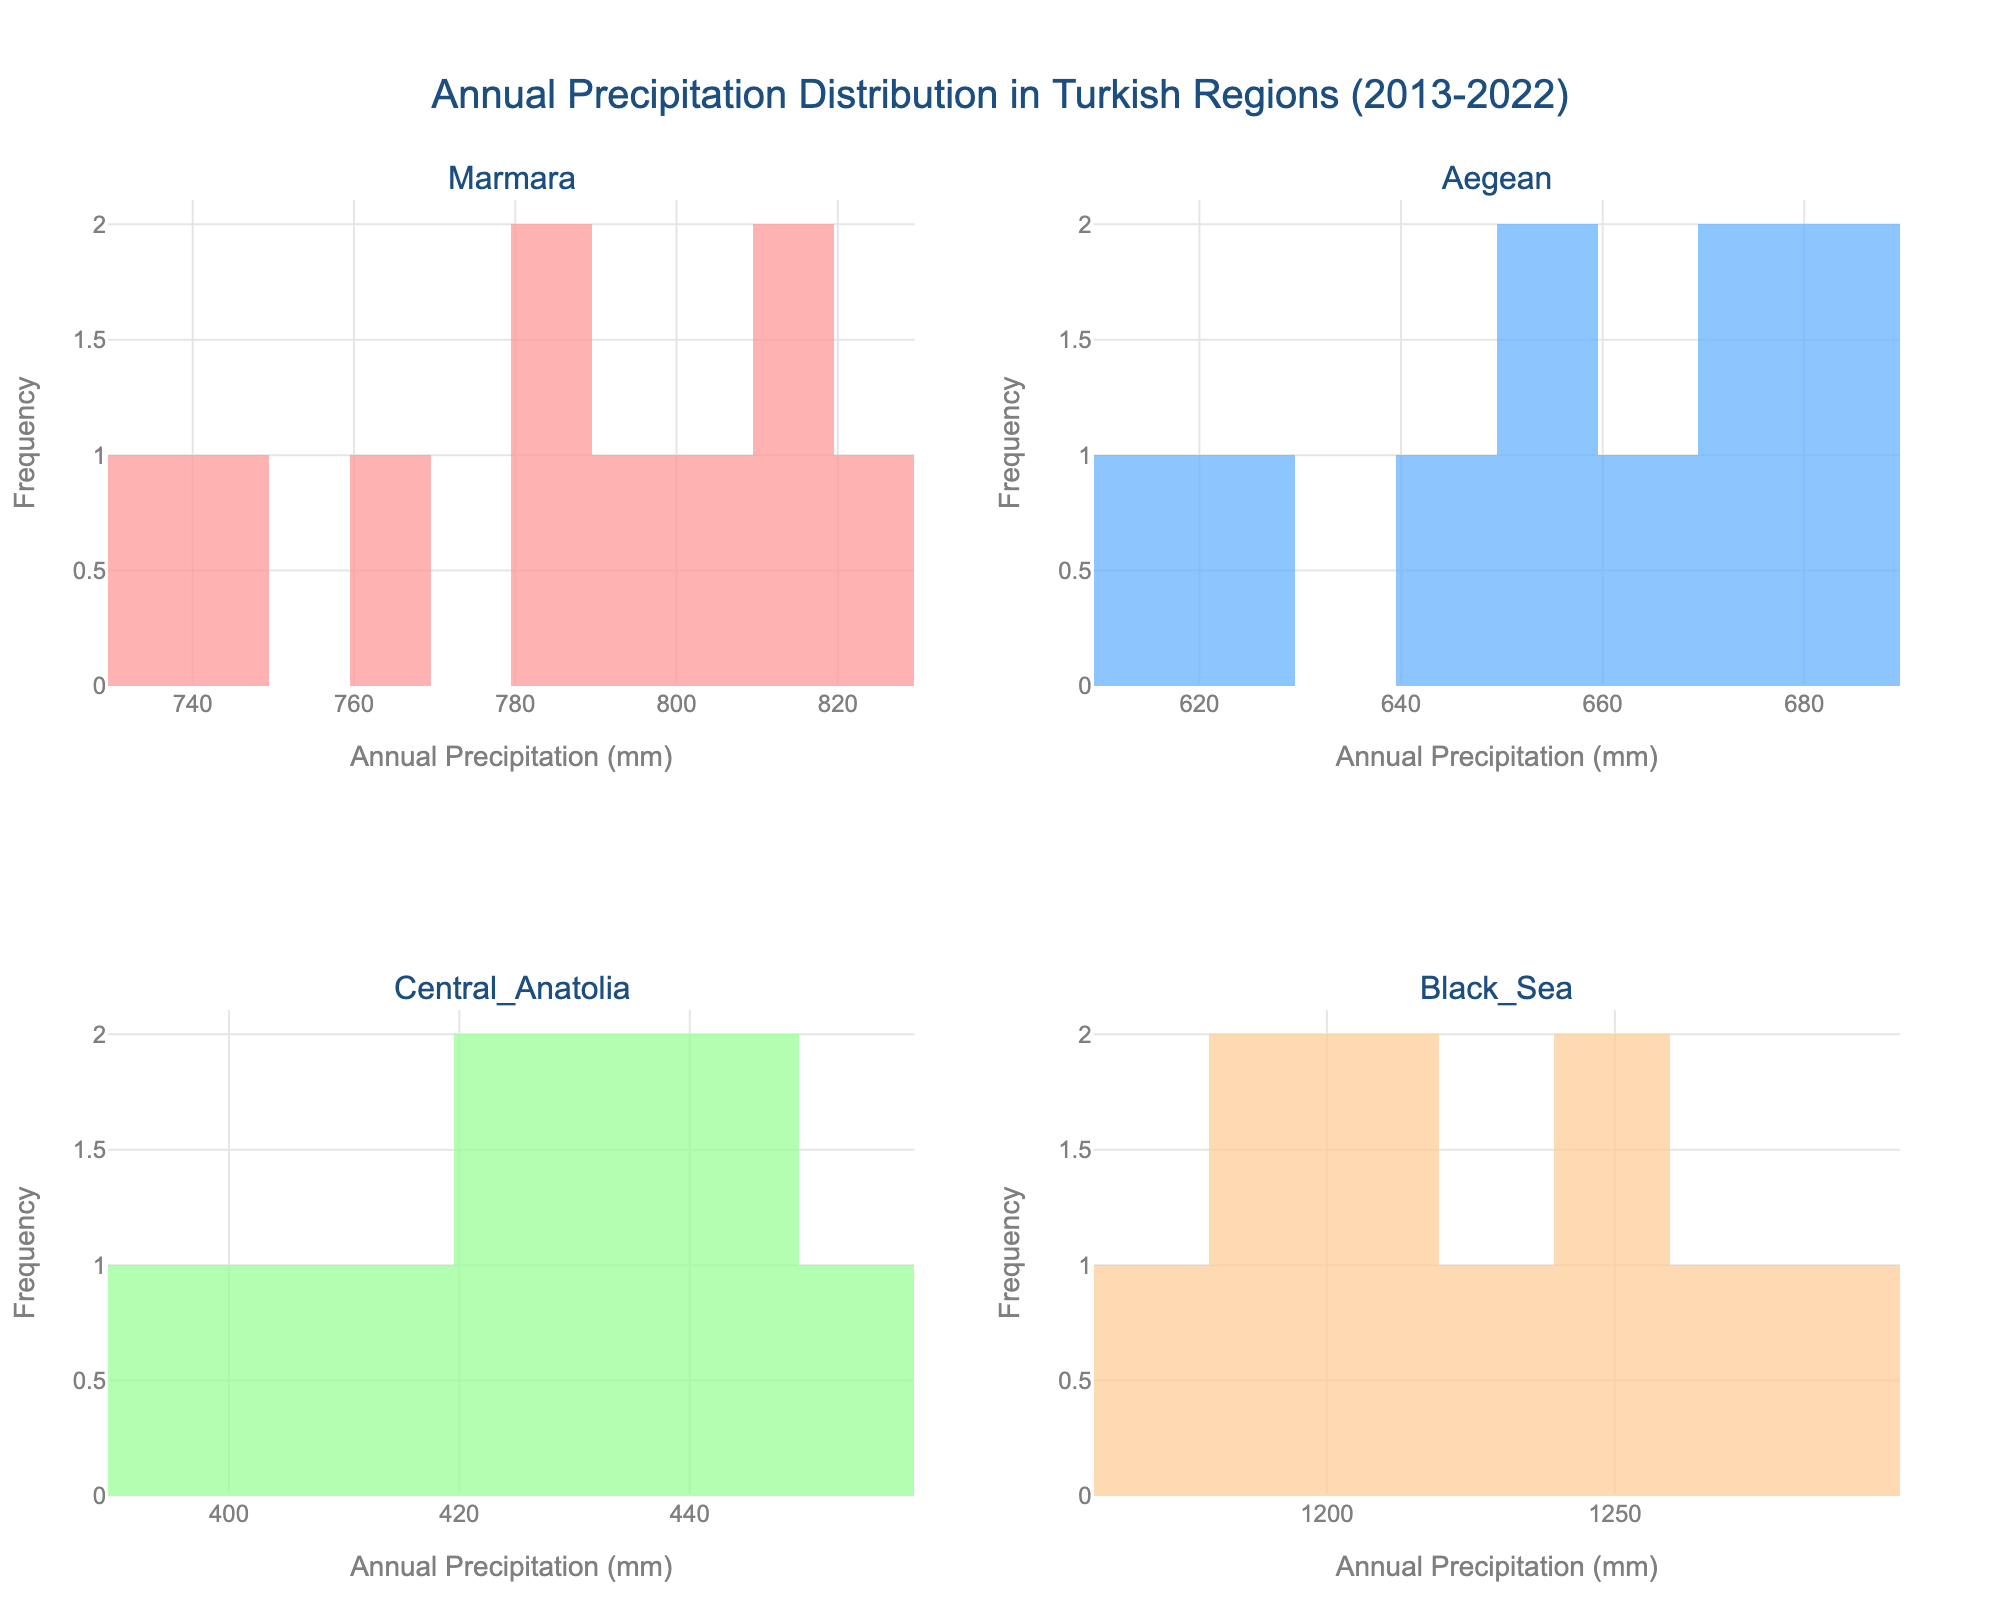What title does the figure have? The title is located at the top of the figure. It reads "Annual Precipitation Distribution in Turkish Regions (2013-2022)".
Answer: Annual Precipitation Distribution in Turkish Regions (2013-2022) What is the highest bin value for the Black Sea region? Observe the histogram for the Black Sea region. Identify the bin with the highest value on the y-axis, which represents frequency.
Answer: 2 Which region experienced the highest annual precipitation? Look for the region with the highest precipitation value on the x-axis of histograms. The Black Sea region's histogram has bins extending up to 1280 mm.
Answer: Black Sea How does the average annual precipitation in the Aegean region compare to the Marmara region? Calculate the average by summing the annual precipitation values for each region and dividing by the number of years. Compare the two averages.
Answer: Marmara is higher What is the most common annual precipitation range for Central Anatolia? Identify the x-axis range with the highest frequency (y-axis) in the Central Anatolia histogram. The most frequent bin range represents the common precipitation range.
Answer: 410-420 mm Which region shows the greatest variability in annual precipitation? Evaluate the spread of the distributions. Wider distributions indicate greater variability. The Black Sea region has the widest spread in its histogram.
Answer: Black Sea In which region is the annual precipitation most consistent? The region with the narrowest spread in the histogram indicates consistent precipitation. Central Anatolia's histogram shows a narrow spread.
Answer: Central Anatolia How do the frequencies of the highest precipitation bins in Marmara and Aegean compare? Identify the bins with the highest precipitation values in both regions and compare their frequencies on the y-axis.
Answer: The Marmara region has slightly higher frequency for the highest precipitation bin compared to Aegean What is the minimum annual precipitation recorded in the Black Sea region? Look for the smallest value on the x-axis in the Black Sea histogram. The minimum value is the leftmost edge of the bins.
Answer: 1170 mm What is the frequency of the bin with precipitation between 780 and 800 mm in Marmara? Find the bin that spans this range on the x-axis in the Marmara histogram and read its frequency on the y-axis.
Answer: 2 